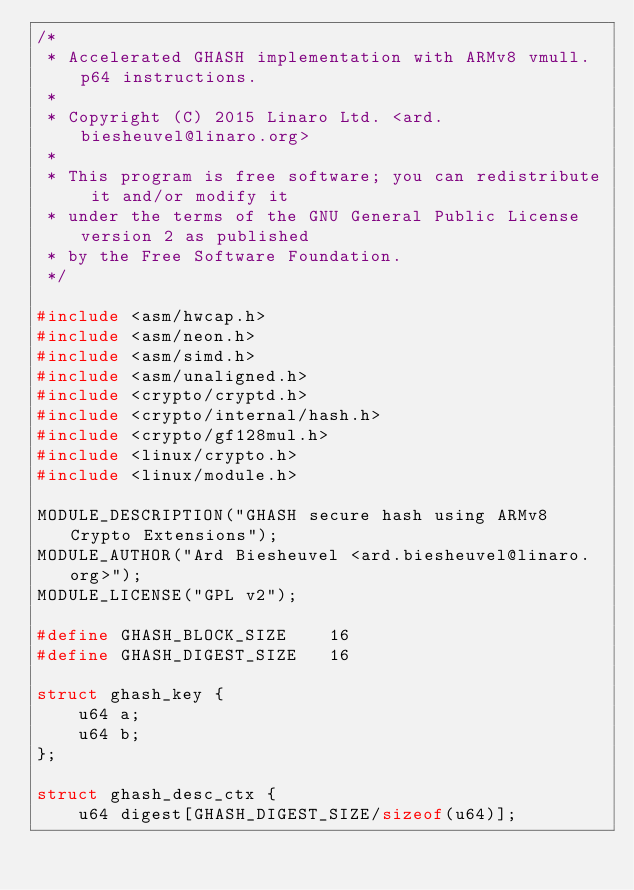<code> <loc_0><loc_0><loc_500><loc_500><_C_>/*
 * Accelerated GHASH implementation with ARMv8 vmull.p64 instructions.
 *
 * Copyright (C) 2015 Linaro Ltd. <ard.biesheuvel@linaro.org>
 *
 * This program is free software; you can redistribute it and/or modify it
 * under the terms of the GNU General Public License version 2 as published
 * by the Free Software Foundation.
 */

#include <asm/hwcap.h>
#include <asm/neon.h>
#include <asm/simd.h>
#include <asm/unaligned.h>
#include <crypto/cryptd.h>
#include <crypto/internal/hash.h>
#include <crypto/gf128mul.h>
#include <linux/crypto.h>
#include <linux/module.h>

MODULE_DESCRIPTION("GHASH secure hash using ARMv8 Crypto Extensions");
MODULE_AUTHOR("Ard Biesheuvel <ard.biesheuvel@linaro.org>");
MODULE_LICENSE("GPL v2");

#define GHASH_BLOCK_SIZE	16
#define GHASH_DIGEST_SIZE	16

struct ghash_key {
	u64	a;
	u64	b;
};

struct ghash_desc_ctx {
	u64 digest[GHASH_DIGEST_SIZE/sizeof(u64)];</code> 